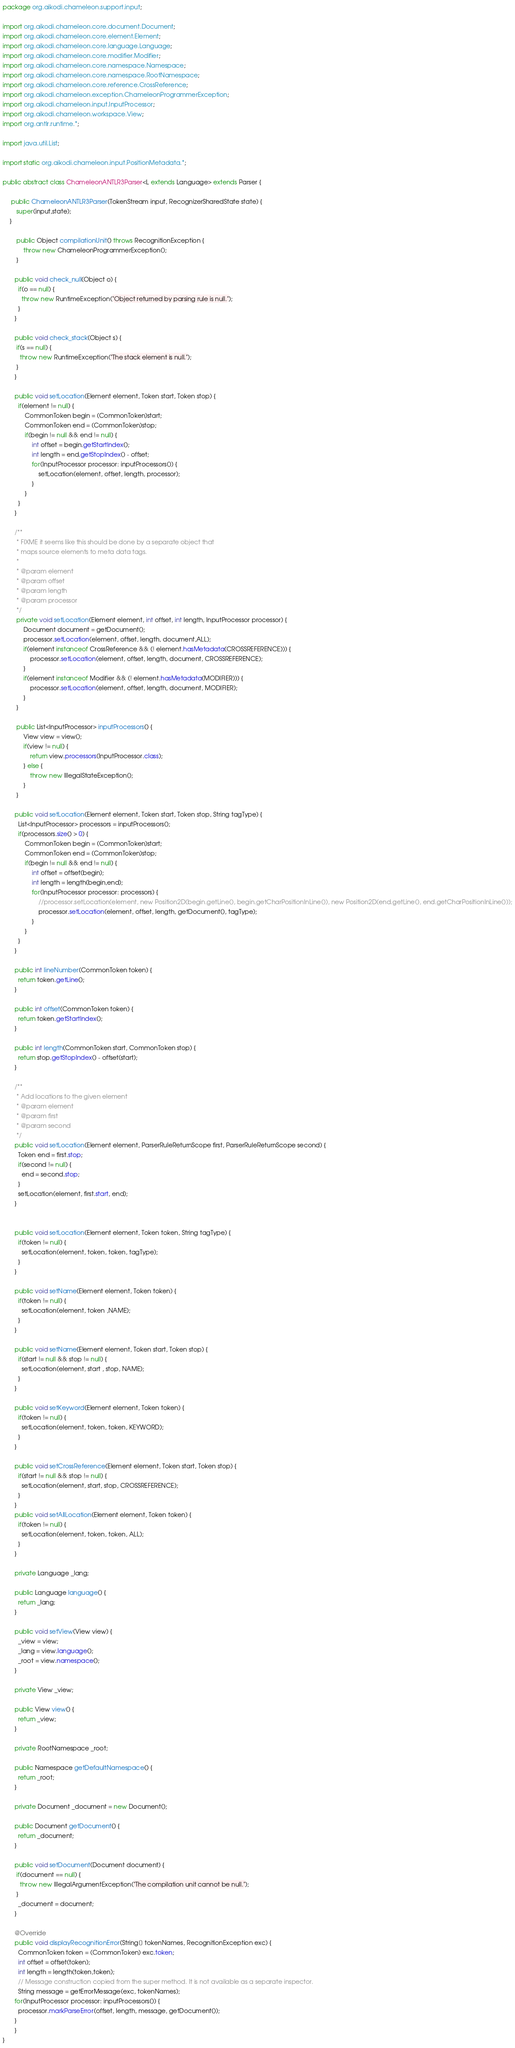Convert code to text. <code><loc_0><loc_0><loc_500><loc_500><_Java_>package org.aikodi.chameleon.support.input;

import org.aikodi.chameleon.core.document.Document;
import org.aikodi.chameleon.core.element.Element;
import org.aikodi.chameleon.core.language.Language;
import org.aikodi.chameleon.core.modifier.Modifier;
import org.aikodi.chameleon.core.namespace.Namespace;
import org.aikodi.chameleon.core.namespace.RootNamespace;
import org.aikodi.chameleon.core.reference.CrossReference;
import org.aikodi.chameleon.exception.ChameleonProgrammerException;
import org.aikodi.chameleon.input.InputProcessor;
import org.aikodi.chameleon.workspace.View;
import org.antlr.runtime.*;

import java.util.List;

import static org.aikodi.chameleon.input.PositionMetadata.*;

public abstract class ChameleonANTLR3Parser<L extends Language> extends Parser {
	
	 public ChameleonANTLR3Parser(TokenStream input, RecognizerSharedState state) {
		super(input,state);
	}

		public Object compilationUnit() throws RecognitionException {
			throw new ChameleonProgrammerException();
		}

	   public void check_null(Object o) {
	     if(o == null) {
	       throw new RuntimeException("Object returned by parsing rule is null.");
	     }
	   }
	   
	   public void check_stack(Object s) {
	    if(s == null) {
	      throw new RuntimeException("The stack element is null.");
	    }
	   }

	   public void setLocation(Element element, Token start, Token stop) {
	  	 if(element != null) {
	  		 CommonToken begin = (CommonToken)start;
	  		 CommonToken end = (CommonToken)stop;
	  		 if(begin != null && end != null) {
	  			 int offset = begin.getStartIndex();
	  			 int length = end.getStopIndex() - offset;
	  			 for(InputProcessor processor: inputProcessors()) {
	  				 setLocation(element, offset, length, processor);
	  			 }
	  		 }
	  	 }
	   }

	   /**
	    * FIXME it seems like this should be done by a separate object that
	    * maps source elements to meta data tags.
	    * 
	    * @param element
	    * @param offset
	    * @param length
	    * @param processor
	    */
		private void setLocation(Element element, int offset, int length, InputProcessor processor) {
			Document document = getDocument();
			processor.setLocation(element, offset, length, document,ALL);
			if(element instanceof CrossReference && (! element.hasMetadata(CROSSREFERENCE))) {
				processor.setLocation(element, offset, length, document, CROSSREFERENCE);
			}
			if(element instanceof Modifier && (! element.hasMetadata(MODIFIER))) {
				processor.setLocation(element, offset, length, document, MODIFIER);
			}
		}
	   
		public List<InputProcessor> inputProcessors() {
			View view = view();
			if(view != null) {
				return view.processors(InputProcessor.class);
			} else {
				throw new IllegalStateException();
			}
		}

	   public void setLocation(Element element, Token start, Token stop, String tagType) {
	     List<InputProcessor> processors = inputProcessors();
	     if(processors.size() > 0) {
	    	 CommonToken begin = (CommonToken)start;
	    	 CommonToken end = (CommonToken)stop;
	    	 if(begin != null && end != null) {
	    		 int offset = offset(begin);
	    		 int length = length(begin,end);
	    		 for(InputProcessor processor: processors) {
	    			 //processor.setLocation(element, new Position2D(begin.getLine(), begin.getCharPositionInLine()), new Position2D(end.getLine(), end.getCharPositionInLine()));
	    			 processor.setLocation(element, offset, length, getDocument(), tagType);
	    		 }
	    	 }
	     }
	   }
	   
	   public int lineNumber(CommonToken token) {
	  	 return token.getLine();
	   }
	   
	   public int offset(CommonToken token) {
	  	 return token.getStartIndex();
	   }
	   
	   public int length(CommonToken start, CommonToken stop) {
	  	 return stop.getStopIndex() - offset(start);
	   }
	   
	   /**
	    * Add locations to the given element
	    * @param element
	    * @param first
	    * @param second
	    */
	   public void setLocation(Element element, ParserRuleReturnScope first, ParserRuleReturnScope second) {
	     Token end = first.stop;
	     if(second != null) {
	       end = second.stop;
	     }
	     setLocation(element, first.start, end);
	   }
	   
	   
	   public void setLocation(Element element, Token token, String tagType) {
	     if(token != null) {
	       setLocation(element, token, token, tagType);
	     }
	   }
	   
	   public void setName(Element element, Token token) {
	  	 if(token != null) {
	  	   setLocation(element, token ,NAME);
	  	 }
	   }
	   
	   public void setName(Element element, Token start, Token stop) {
	  	 if(start != null && stop != null) {
	  	   setLocation(element, start , stop, NAME);
	  	 }
	   }
	   	   
	   public void setKeyword(Element element, Token token) {
	     if(token != null) {
	       setLocation(element, token, token, KEYWORD);
	     }
	   }
	   
	   public void setCrossReference(Element element, Token start, Token stop) {
	     if(start != null && stop != null) {
	       setLocation(element, start, stop, CROSSREFERENCE);
	     }
	   }
	   public void setAllLocation(Element element, Token token) {
	     if(token != null) {
	       setLocation(element, token, token, ALL);
	     }
	   }
	   
	   private Language _lang;
	   
	   public Language language() {
	     return _lang;
	   }
	   
	   public void setView(View view) {
	  	 _view = view;
	     _lang = view.language();
	     _root = view.namespace();
	   }
	   
	   private View _view;
	   
	   public View view() {
	  	 return _view;
	   }
	   
	   private RootNamespace _root;

	   public Namespace getDefaultNamespace() {
	     return _root;
	   }

	   private Document _document = new Document();
	   
	   public Document getDocument() {
	     return _document;
	   }
	   
	   public void setDocument(Document document) {
	    if(document == null) {
	      throw new IllegalArgumentException("The compilation unit cannot be null.");
	    }
	     _document = document;
	   }
	   
	   @Override
	   public void displayRecognitionError(String[] tokenNames, RecognitionException exc) {
	   	 CommonToken token = (CommonToken) exc.token;
	   	 int offset = offset(token);
	   	 int length = length(token,token);
	   	 // Message construction copied from the super method. It is not available as a separate inspector.
	   	 String message = getErrorMessage(exc, tokenNames);
       for(InputProcessor processor: inputProcessors()) {
      	 processor.markParseError(offset, length, message, getDocument());
       }
	   }
}
</code> 